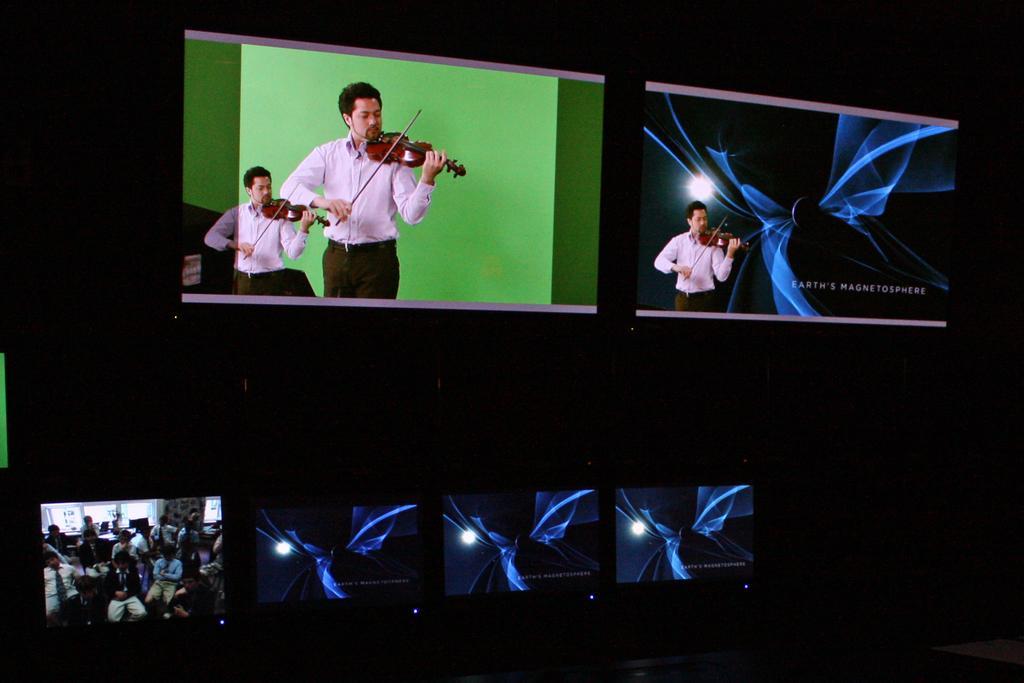Describe this image in one or two sentences. In the picture we can see a man holding violin and playing it. A man is wearing a white shirt with black pant. In the background we can see a same image of a person and there is a green wall in the background. In the second image we can see a same person holding a violin and playing it in the background we can find a blue animated background. 